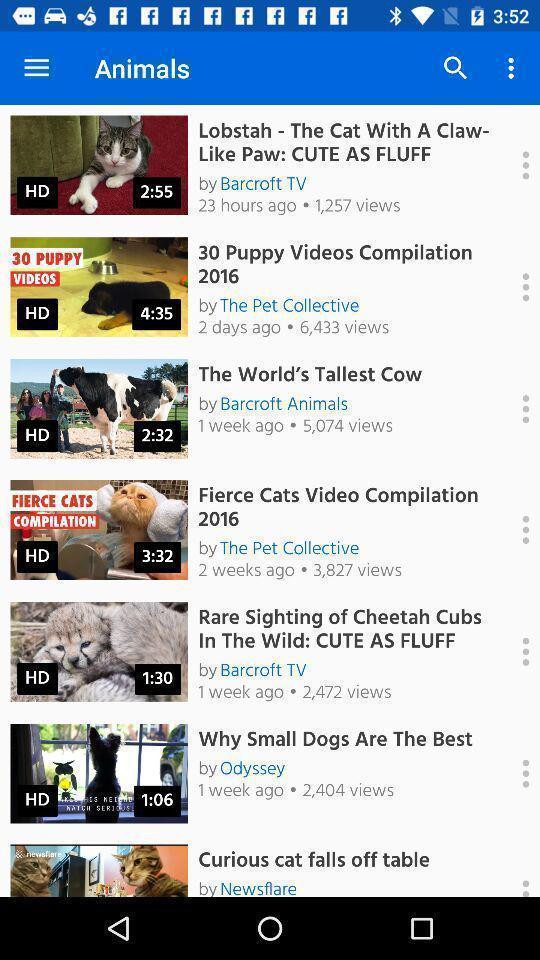Describe the content in this image. Screen displaying a list of animal videos. 